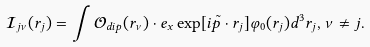<formula> <loc_0><loc_0><loc_500><loc_500>\mathcal { I } _ { j \nu } ( r _ { j } ) = \int \mathcal { O } _ { d i p } ( r _ { \nu } ) \cdot e _ { x } \exp [ i \tilde { p } \cdot r _ { j } ] \varphi _ { 0 } ( r _ { j } ) d ^ { 3 } r _ { j } , \nu \neq j . \</formula> 